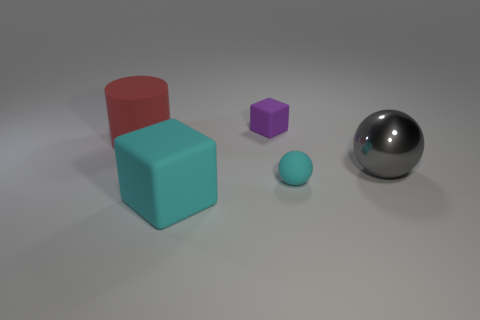There is a large object that is both behind the cyan block and left of the large gray metallic sphere; what shape is it?
Offer a very short reply. Cylinder. What is the material of the large cyan cube?
Offer a terse response. Rubber. What number of blocks are either big blue objects or metal objects?
Keep it short and to the point. 0. Is the large cube made of the same material as the red cylinder?
Give a very brief answer. Yes. There is a purple rubber object that is the same shape as the big cyan rubber object; what size is it?
Your answer should be compact. Small. What material is the thing that is both behind the small ball and on the left side of the tiny purple rubber cube?
Your answer should be very brief. Rubber. Is the number of large rubber blocks that are behind the rubber cylinder the same as the number of large red cylinders?
Your answer should be very brief. No. How many things are either matte objects in front of the large gray thing or red cylinders?
Offer a terse response. 3. There is a cube in front of the gray object; is its color the same as the tiny cube?
Offer a very short reply. No. There is a block that is behind the tiny cyan ball; how big is it?
Offer a terse response. Small. 